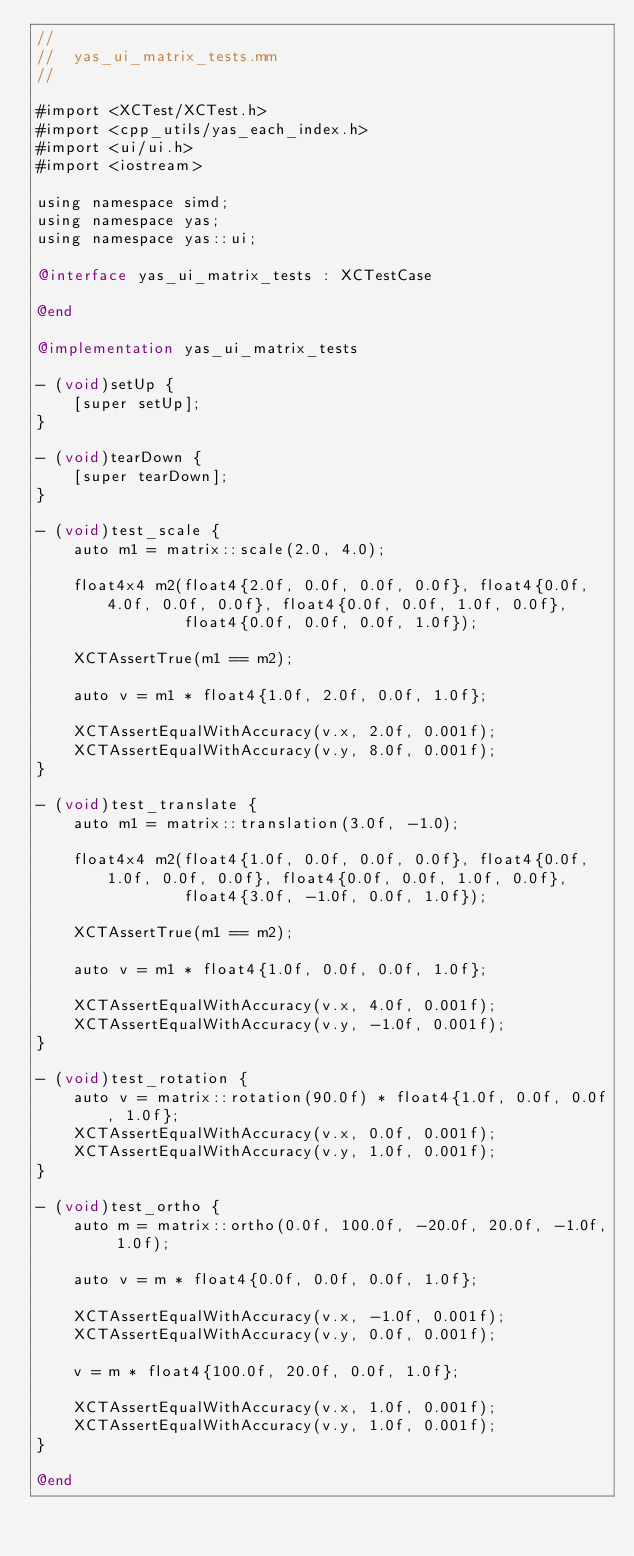Convert code to text. <code><loc_0><loc_0><loc_500><loc_500><_ObjectiveC_>//
//  yas_ui_matrix_tests.mm
//

#import <XCTest/XCTest.h>
#import <cpp_utils/yas_each_index.h>
#import <ui/ui.h>
#import <iostream>

using namespace simd;
using namespace yas;
using namespace yas::ui;

@interface yas_ui_matrix_tests : XCTestCase

@end

@implementation yas_ui_matrix_tests

- (void)setUp {
    [super setUp];
}

- (void)tearDown {
    [super tearDown];
}

- (void)test_scale {
    auto m1 = matrix::scale(2.0, 4.0);

    float4x4 m2(float4{2.0f, 0.0f, 0.0f, 0.0f}, float4{0.0f, 4.0f, 0.0f, 0.0f}, float4{0.0f, 0.0f, 1.0f, 0.0f},
                float4{0.0f, 0.0f, 0.0f, 1.0f});

    XCTAssertTrue(m1 == m2);

    auto v = m1 * float4{1.0f, 2.0f, 0.0f, 1.0f};

    XCTAssertEqualWithAccuracy(v.x, 2.0f, 0.001f);
    XCTAssertEqualWithAccuracy(v.y, 8.0f, 0.001f);
}

- (void)test_translate {
    auto m1 = matrix::translation(3.0f, -1.0);

    float4x4 m2(float4{1.0f, 0.0f, 0.0f, 0.0f}, float4{0.0f, 1.0f, 0.0f, 0.0f}, float4{0.0f, 0.0f, 1.0f, 0.0f},
                float4{3.0f, -1.0f, 0.0f, 1.0f});

    XCTAssertTrue(m1 == m2);

    auto v = m1 * float4{1.0f, 0.0f, 0.0f, 1.0f};

    XCTAssertEqualWithAccuracy(v.x, 4.0f, 0.001f);
    XCTAssertEqualWithAccuracy(v.y, -1.0f, 0.001f);
}

- (void)test_rotation {
    auto v = matrix::rotation(90.0f) * float4{1.0f, 0.0f, 0.0f, 1.0f};
    XCTAssertEqualWithAccuracy(v.x, 0.0f, 0.001f);
    XCTAssertEqualWithAccuracy(v.y, 1.0f, 0.001f);
}

- (void)test_ortho {
    auto m = matrix::ortho(0.0f, 100.0f, -20.0f, 20.0f, -1.0f, 1.0f);

    auto v = m * float4{0.0f, 0.0f, 0.0f, 1.0f};

    XCTAssertEqualWithAccuracy(v.x, -1.0f, 0.001f);
    XCTAssertEqualWithAccuracy(v.y, 0.0f, 0.001f);

    v = m * float4{100.0f, 20.0f, 0.0f, 1.0f};

    XCTAssertEqualWithAccuracy(v.x, 1.0f, 0.001f);
    XCTAssertEqualWithAccuracy(v.y, 1.0f, 0.001f);
}

@end
</code> 